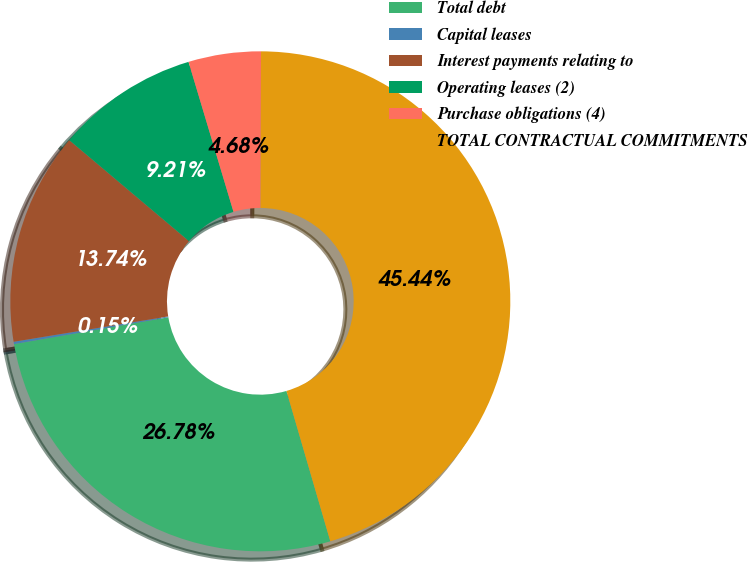<chart> <loc_0><loc_0><loc_500><loc_500><pie_chart><fcel>Total debt<fcel>Capital leases<fcel>Interest payments relating to<fcel>Operating leases (2)<fcel>Purchase obligations (4)<fcel>TOTAL CONTRACTUAL COMMITMENTS<nl><fcel>26.78%<fcel>0.15%<fcel>13.74%<fcel>9.21%<fcel>4.68%<fcel>45.44%<nl></chart> 